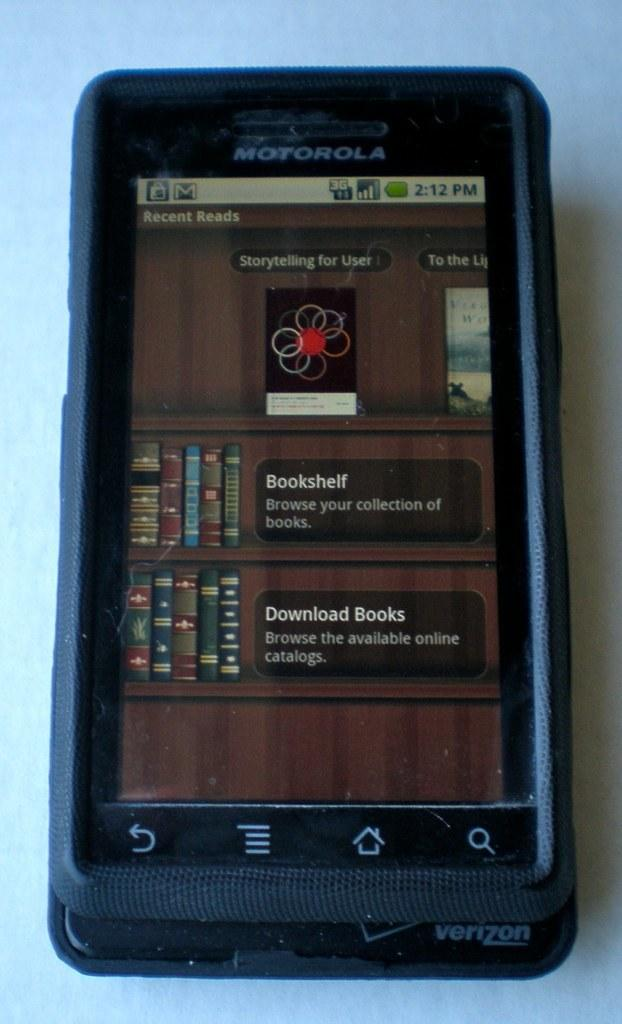<image>
Summarize the visual content of the image. Motorola phone sits on a table displaying a bookshelf 